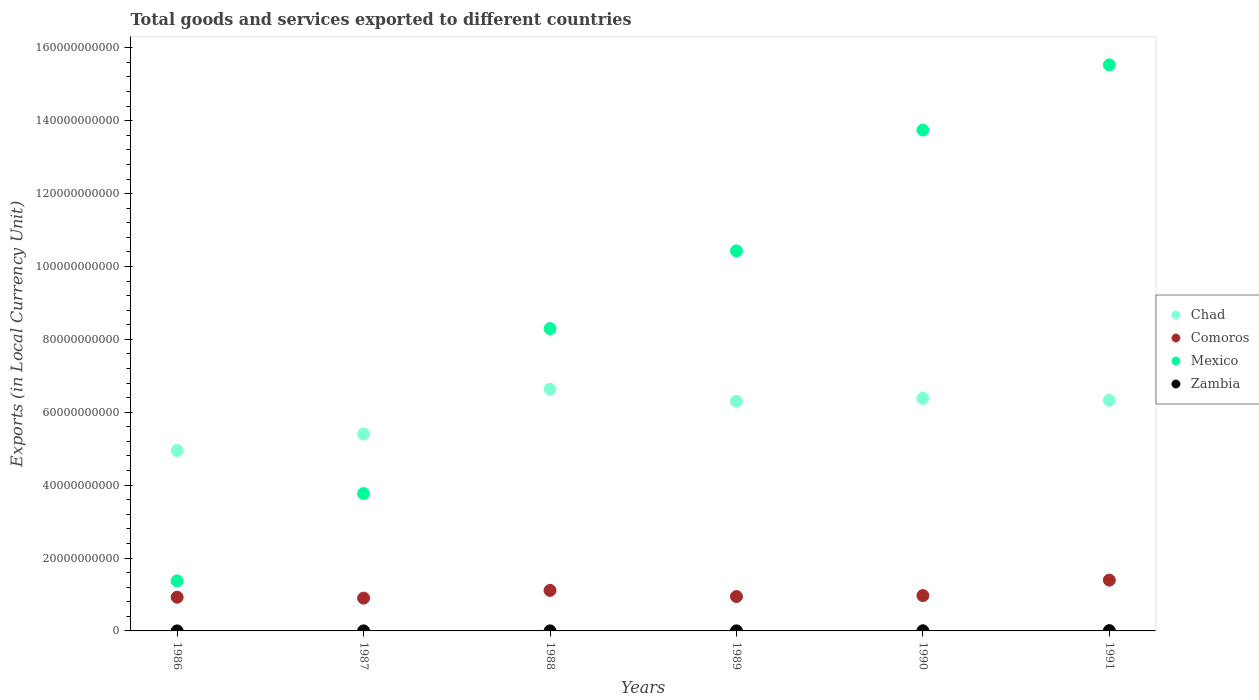How many different coloured dotlines are there?
Offer a terse response. 4. Is the number of dotlines equal to the number of legend labels?
Ensure brevity in your answer.  Yes. What is the Amount of goods and services exports in Mexico in 1986?
Your answer should be compact. 1.37e+1. Across all years, what is the maximum Amount of goods and services exports in Zambia?
Give a very brief answer. 7.56e+07. Across all years, what is the minimum Amount of goods and services exports in Zambia?
Provide a short and direct response. 5.46e+06. In which year was the Amount of goods and services exports in Mexico minimum?
Provide a short and direct response. 1986. What is the total Amount of goods and services exports in Chad in the graph?
Your answer should be very brief. 3.60e+11. What is the difference between the Amount of goods and services exports in Mexico in 1990 and that in 1991?
Your response must be concise. -1.79e+1. What is the difference between the Amount of goods and services exports in Chad in 1991 and the Amount of goods and services exports in Zambia in 1988?
Keep it short and to the point. 6.33e+1. What is the average Amount of goods and services exports in Mexico per year?
Offer a very short reply. 8.86e+1. In the year 1987, what is the difference between the Amount of goods and services exports in Comoros and Amount of goods and services exports in Chad?
Your answer should be compact. -4.50e+1. In how many years, is the Amount of goods and services exports in Mexico greater than 32000000000 LCU?
Offer a terse response. 5. What is the ratio of the Amount of goods and services exports in Zambia in 1987 to that in 1990?
Your answer should be compact. 0.21. Is the difference between the Amount of goods and services exports in Comoros in 1987 and 1990 greater than the difference between the Amount of goods and services exports in Chad in 1987 and 1990?
Your answer should be very brief. Yes. What is the difference between the highest and the second highest Amount of goods and services exports in Comoros?
Provide a succinct answer. 2.82e+09. What is the difference between the highest and the lowest Amount of goods and services exports in Chad?
Provide a short and direct response. 1.68e+1. Is it the case that in every year, the sum of the Amount of goods and services exports in Zambia and Amount of goods and services exports in Mexico  is greater than the Amount of goods and services exports in Chad?
Ensure brevity in your answer.  No. What is the difference between two consecutive major ticks on the Y-axis?
Your response must be concise. 2.00e+1. Where does the legend appear in the graph?
Give a very brief answer. Center right. What is the title of the graph?
Keep it short and to the point. Total goods and services exported to different countries. What is the label or title of the Y-axis?
Make the answer very short. Exports (in Local Currency Unit). What is the Exports (in Local Currency Unit) in Chad in 1986?
Offer a terse response. 4.95e+1. What is the Exports (in Local Currency Unit) in Comoros in 1986?
Offer a terse response. 9.25e+09. What is the Exports (in Local Currency Unit) of Mexico in 1986?
Your answer should be very brief. 1.37e+1. What is the Exports (in Local Currency Unit) in Zambia in 1986?
Provide a succinct answer. 5.46e+06. What is the Exports (in Local Currency Unit) of Chad in 1987?
Provide a succinct answer. 5.40e+1. What is the Exports (in Local Currency Unit) in Comoros in 1987?
Provide a succinct answer. 9.00e+09. What is the Exports (in Local Currency Unit) of Mexico in 1987?
Offer a terse response. 3.77e+1. What is the Exports (in Local Currency Unit) in Zambia in 1987?
Your answer should be compact. 8.51e+06. What is the Exports (in Local Currency Unit) of Chad in 1988?
Offer a very short reply. 6.63e+1. What is the Exports (in Local Currency Unit) of Comoros in 1988?
Make the answer very short. 1.11e+1. What is the Exports (in Local Currency Unit) of Mexico in 1988?
Give a very brief answer. 8.30e+1. What is the Exports (in Local Currency Unit) in Zambia in 1988?
Your response must be concise. 1.03e+07. What is the Exports (in Local Currency Unit) of Chad in 1989?
Ensure brevity in your answer.  6.30e+1. What is the Exports (in Local Currency Unit) of Comoros in 1989?
Your answer should be very brief. 9.44e+09. What is the Exports (in Local Currency Unit) of Mexico in 1989?
Offer a very short reply. 1.04e+11. What is the Exports (in Local Currency Unit) in Zambia in 1989?
Give a very brief answer. 1.48e+07. What is the Exports (in Local Currency Unit) in Chad in 1990?
Your response must be concise. 6.38e+1. What is the Exports (in Local Currency Unit) in Comoros in 1990?
Give a very brief answer. 9.70e+09. What is the Exports (in Local Currency Unit) of Mexico in 1990?
Make the answer very short. 1.37e+11. What is the Exports (in Local Currency Unit) in Zambia in 1990?
Your answer should be compact. 4.07e+07. What is the Exports (in Local Currency Unit) in Chad in 1991?
Keep it short and to the point. 6.33e+1. What is the Exports (in Local Currency Unit) in Comoros in 1991?
Make the answer very short. 1.39e+1. What is the Exports (in Local Currency Unit) in Mexico in 1991?
Offer a very short reply. 1.55e+11. What is the Exports (in Local Currency Unit) of Zambia in 1991?
Your answer should be compact. 7.56e+07. Across all years, what is the maximum Exports (in Local Currency Unit) in Chad?
Provide a short and direct response. 6.63e+1. Across all years, what is the maximum Exports (in Local Currency Unit) in Comoros?
Give a very brief answer. 1.39e+1. Across all years, what is the maximum Exports (in Local Currency Unit) in Mexico?
Your response must be concise. 1.55e+11. Across all years, what is the maximum Exports (in Local Currency Unit) in Zambia?
Your answer should be very brief. 7.56e+07. Across all years, what is the minimum Exports (in Local Currency Unit) in Chad?
Your answer should be compact. 4.95e+1. Across all years, what is the minimum Exports (in Local Currency Unit) of Comoros?
Your answer should be compact. 9.00e+09. Across all years, what is the minimum Exports (in Local Currency Unit) in Mexico?
Make the answer very short. 1.37e+1. Across all years, what is the minimum Exports (in Local Currency Unit) of Zambia?
Give a very brief answer. 5.46e+06. What is the total Exports (in Local Currency Unit) of Chad in the graph?
Give a very brief answer. 3.60e+11. What is the total Exports (in Local Currency Unit) in Comoros in the graph?
Your response must be concise. 6.24e+1. What is the total Exports (in Local Currency Unit) of Mexico in the graph?
Ensure brevity in your answer.  5.31e+11. What is the total Exports (in Local Currency Unit) of Zambia in the graph?
Offer a very short reply. 1.55e+08. What is the difference between the Exports (in Local Currency Unit) of Chad in 1986 and that in 1987?
Give a very brief answer. -4.49e+09. What is the difference between the Exports (in Local Currency Unit) in Comoros in 1986 and that in 1987?
Your response must be concise. 2.51e+08. What is the difference between the Exports (in Local Currency Unit) of Mexico in 1986 and that in 1987?
Provide a succinct answer. -2.40e+1. What is the difference between the Exports (in Local Currency Unit) of Zambia in 1986 and that in 1987?
Offer a terse response. -3.05e+06. What is the difference between the Exports (in Local Currency Unit) in Chad in 1986 and that in 1988?
Give a very brief answer. -1.68e+1. What is the difference between the Exports (in Local Currency Unit) of Comoros in 1986 and that in 1988?
Offer a terse response. -1.86e+09. What is the difference between the Exports (in Local Currency Unit) of Mexico in 1986 and that in 1988?
Your answer should be very brief. -6.92e+1. What is the difference between the Exports (in Local Currency Unit) of Zambia in 1986 and that in 1988?
Ensure brevity in your answer.  -4.80e+06. What is the difference between the Exports (in Local Currency Unit) in Chad in 1986 and that in 1989?
Provide a short and direct response. -1.35e+1. What is the difference between the Exports (in Local Currency Unit) in Comoros in 1986 and that in 1989?
Give a very brief answer. -1.84e+08. What is the difference between the Exports (in Local Currency Unit) of Mexico in 1986 and that in 1989?
Give a very brief answer. -9.05e+1. What is the difference between the Exports (in Local Currency Unit) in Zambia in 1986 and that in 1989?
Make the answer very short. -9.33e+06. What is the difference between the Exports (in Local Currency Unit) in Chad in 1986 and that in 1990?
Offer a terse response. -1.43e+1. What is the difference between the Exports (in Local Currency Unit) of Comoros in 1986 and that in 1990?
Give a very brief answer. -4.51e+08. What is the difference between the Exports (in Local Currency Unit) in Mexico in 1986 and that in 1990?
Provide a succinct answer. -1.24e+11. What is the difference between the Exports (in Local Currency Unit) in Zambia in 1986 and that in 1990?
Offer a terse response. -3.52e+07. What is the difference between the Exports (in Local Currency Unit) in Chad in 1986 and that in 1991?
Provide a succinct answer. -1.38e+1. What is the difference between the Exports (in Local Currency Unit) of Comoros in 1986 and that in 1991?
Ensure brevity in your answer.  -4.68e+09. What is the difference between the Exports (in Local Currency Unit) of Mexico in 1986 and that in 1991?
Make the answer very short. -1.42e+11. What is the difference between the Exports (in Local Currency Unit) in Zambia in 1986 and that in 1991?
Make the answer very short. -7.01e+07. What is the difference between the Exports (in Local Currency Unit) in Chad in 1987 and that in 1988?
Your response must be concise. -1.23e+1. What is the difference between the Exports (in Local Currency Unit) of Comoros in 1987 and that in 1988?
Ensure brevity in your answer.  -2.11e+09. What is the difference between the Exports (in Local Currency Unit) in Mexico in 1987 and that in 1988?
Your answer should be very brief. -4.53e+1. What is the difference between the Exports (in Local Currency Unit) in Zambia in 1987 and that in 1988?
Your answer should be compact. -1.75e+06. What is the difference between the Exports (in Local Currency Unit) of Chad in 1987 and that in 1989?
Provide a succinct answer. -9.01e+09. What is the difference between the Exports (in Local Currency Unit) of Comoros in 1987 and that in 1989?
Your answer should be compact. -4.35e+08. What is the difference between the Exports (in Local Currency Unit) in Mexico in 1987 and that in 1989?
Provide a succinct answer. -6.66e+1. What is the difference between the Exports (in Local Currency Unit) of Zambia in 1987 and that in 1989?
Ensure brevity in your answer.  -6.28e+06. What is the difference between the Exports (in Local Currency Unit) in Chad in 1987 and that in 1990?
Ensure brevity in your answer.  -9.79e+09. What is the difference between the Exports (in Local Currency Unit) of Comoros in 1987 and that in 1990?
Give a very brief answer. -7.02e+08. What is the difference between the Exports (in Local Currency Unit) in Mexico in 1987 and that in 1990?
Ensure brevity in your answer.  -9.97e+1. What is the difference between the Exports (in Local Currency Unit) in Zambia in 1987 and that in 1990?
Your answer should be very brief. -3.22e+07. What is the difference between the Exports (in Local Currency Unit) of Chad in 1987 and that in 1991?
Provide a short and direct response. -9.27e+09. What is the difference between the Exports (in Local Currency Unit) in Comoros in 1987 and that in 1991?
Provide a short and direct response. -4.93e+09. What is the difference between the Exports (in Local Currency Unit) in Mexico in 1987 and that in 1991?
Your response must be concise. -1.18e+11. What is the difference between the Exports (in Local Currency Unit) of Zambia in 1987 and that in 1991?
Keep it short and to the point. -6.70e+07. What is the difference between the Exports (in Local Currency Unit) of Chad in 1988 and that in 1989?
Ensure brevity in your answer.  3.29e+09. What is the difference between the Exports (in Local Currency Unit) in Comoros in 1988 and that in 1989?
Your response must be concise. 1.68e+09. What is the difference between the Exports (in Local Currency Unit) in Mexico in 1988 and that in 1989?
Your answer should be compact. -2.13e+1. What is the difference between the Exports (in Local Currency Unit) in Zambia in 1988 and that in 1989?
Your answer should be very brief. -4.53e+06. What is the difference between the Exports (in Local Currency Unit) in Chad in 1988 and that in 1990?
Provide a succinct answer. 2.51e+09. What is the difference between the Exports (in Local Currency Unit) in Comoros in 1988 and that in 1990?
Offer a terse response. 1.41e+09. What is the difference between the Exports (in Local Currency Unit) of Mexico in 1988 and that in 1990?
Give a very brief answer. -5.45e+1. What is the difference between the Exports (in Local Currency Unit) in Zambia in 1988 and that in 1990?
Keep it short and to the point. -3.04e+07. What is the difference between the Exports (in Local Currency Unit) in Chad in 1988 and that in 1991?
Keep it short and to the point. 3.03e+09. What is the difference between the Exports (in Local Currency Unit) in Comoros in 1988 and that in 1991?
Ensure brevity in your answer.  -2.82e+09. What is the difference between the Exports (in Local Currency Unit) of Mexico in 1988 and that in 1991?
Offer a terse response. -7.24e+1. What is the difference between the Exports (in Local Currency Unit) of Zambia in 1988 and that in 1991?
Your response must be concise. -6.53e+07. What is the difference between the Exports (in Local Currency Unit) in Chad in 1989 and that in 1990?
Give a very brief answer. -7.80e+08. What is the difference between the Exports (in Local Currency Unit) of Comoros in 1989 and that in 1990?
Give a very brief answer. -2.67e+08. What is the difference between the Exports (in Local Currency Unit) of Mexico in 1989 and that in 1990?
Provide a succinct answer. -3.32e+1. What is the difference between the Exports (in Local Currency Unit) of Zambia in 1989 and that in 1990?
Your response must be concise. -2.59e+07. What is the difference between the Exports (in Local Currency Unit) of Chad in 1989 and that in 1991?
Provide a succinct answer. -2.60e+08. What is the difference between the Exports (in Local Currency Unit) in Comoros in 1989 and that in 1991?
Make the answer very short. -4.50e+09. What is the difference between the Exports (in Local Currency Unit) in Mexico in 1989 and that in 1991?
Make the answer very short. -5.11e+1. What is the difference between the Exports (in Local Currency Unit) in Zambia in 1989 and that in 1991?
Provide a succinct answer. -6.08e+07. What is the difference between the Exports (in Local Currency Unit) of Chad in 1990 and that in 1991?
Give a very brief answer. 5.20e+08. What is the difference between the Exports (in Local Currency Unit) in Comoros in 1990 and that in 1991?
Your response must be concise. -4.23e+09. What is the difference between the Exports (in Local Currency Unit) of Mexico in 1990 and that in 1991?
Make the answer very short. -1.79e+1. What is the difference between the Exports (in Local Currency Unit) of Zambia in 1990 and that in 1991?
Provide a short and direct response. -3.49e+07. What is the difference between the Exports (in Local Currency Unit) of Chad in 1986 and the Exports (in Local Currency Unit) of Comoros in 1987?
Offer a very short reply. 4.05e+1. What is the difference between the Exports (in Local Currency Unit) in Chad in 1986 and the Exports (in Local Currency Unit) in Mexico in 1987?
Your response must be concise. 1.18e+1. What is the difference between the Exports (in Local Currency Unit) in Chad in 1986 and the Exports (in Local Currency Unit) in Zambia in 1987?
Give a very brief answer. 4.95e+1. What is the difference between the Exports (in Local Currency Unit) in Comoros in 1986 and the Exports (in Local Currency Unit) in Mexico in 1987?
Give a very brief answer. -2.84e+1. What is the difference between the Exports (in Local Currency Unit) in Comoros in 1986 and the Exports (in Local Currency Unit) in Zambia in 1987?
Provide a short and direct response. 9.24e+09. What is the difference between the Exports (in Local Currency Unit) in Mexico in 1986 and the Exports (in Local Currency Unit) in Zambia in 1987?
Your answer should be very brief. 1.37e+1. What is the difference between the Exports (in Local Currency Unit) in Chad in 1986 and the Exports (in Local Currency Unit) in Comoros in 1988?
Ensure brevity in your answer.  3.84e+1. What is the difference between the Exports (in Local Currency Unit) in Chad in 1986 and the Exports (in Local Currency Unit) in Mexico in 1988?
Give a very brief answer. -3.34e+1. What is the difference between the Exports (in Local Currency Unit) of Chad in 1986 and the Exports (in Local Currency Unit) of Zambia in 1988?
Your answer should be compact. 4.95e+1. What is the difference between the Exports (in Local Currency Unit) of Comoros in 1986 and the Exports (in Local Currency Unit) of Mexico in 1988?
Offer a very short reply. -7.37e+1. What is the difference between the Exports (in Local Currency Unit) of Comoros in 1986 and the Exports (in Local Currency Unit) of Zambia in 1988?
Offer a very short reply. 9.24e+09. What is the difference between the Exports (in Local Currency Unit) of Mexico in 1986 and the Exports (in Local Currency Unit) of Zambia in 1988?
Keep it short and to the point. 1.37e+1. What is the difference between the Exports (in Local Currency Unit) of Chad in 1986 and the Exports (in Local Currency Unit) of Comoros in 1989?
Ensure brevity in your answer.  4.01e+1. What is the difference between the Exports (in Local Currency Unit) in Chad in 1986 and the Exports (in Local Currency Unit) in Mexico in 1989?
Your response must be concise. -5.47e+1. What is the difference between the Exports (in Local Currency Unit) in Chad in 1986 and the Exports (in Local Currency Unit) in Zambia in 1989?
Offer a very short reply. 4.95e+1. What is the difference between the Exports (in Local Currency Unit) in Comoros in 1986 and the Exports (in Local Currency Unit) in Mexico in 1989?
Keep it short and to the point. -9.50e+1. What is the difference between the Exports (in Local Currency Unit) in Comoros in 1986 and the Exports (in Local Currency Unit) in Zambia in 1989?
Provide a succinct answer. 9.24e+09. What is the difference between the Exports (in Local Currency Unit) of Mexico in 1986 and the Exports (in Local Currency Unit) of Zambia in 1989?
Provide a succinct answer. 1.37e+1. What is the difference between the Exports (in Local Currency Unit) of Chad in 1986 and the Exports (in Local Currency Unit) of Comoros in 1990?
Provide a succinct answer. 3.98e+1. What is the difference between the Exports (in Local Currency Unit) in Chad in 1986 and the Exports (in Local Currency Unit) in Mexico in 1990?
Your answer should be very brief. -8.79e+1. What is the difference between the Exports (in Local Currency Unit) in Chad in 1986 and the Exports (in Local Currency Unit) in Zambia in 1990?
Keep it short and to the point. 4.95e+1. What is the difference between the Exports (in Local Currency Unit) of Comoros in 1986 and the Exports (in Local Currency Unit) of Mexico in 1990?
Provide a succinct answer. -1.28e+11. What is the difference between the Exports (in Local Currency Unit) of Comoros in 1986 and the Exports (in Local Currency Unit) of Zambia in 1990?
Provide a succinct answer. 9.21e+09. What is the difference between the Exports (in Local Currency Unit) in Mexico in 1986 and the Exports (in Local Currency Unit) in Zambia in 1990?
Offer a very short reply. 1.37e+1. What is the difference between the Exports (in Local Currency Unit) in Chad in 1986 and the Exports (in Local Currency Unit) in Comoros in 1991?
Your answer should be compact. 3.56e+1. What is the difference between the Exports (in Local Currency Unit) of Chad in 1986 and the Exports (in Local Currency Unit) of Mexico in 1991?
Offer a terse response. -1.06e+11. What is the difference between the Exports (in Local Currency Unit) in Chad in 1986 and the Exports (in Local Currency Unit) in Zambia in 1991?
Your answer should be compact. 4.95e+1. What is the difference between the Exports (in Local Currency Unit) in Comoros in 1986 and the Exports (in Local Currency Unit) in Mexico in 1991?
Offer a very short reply. -1.46e+11. What is the difference between the Exports (in Local Currency Unit) of Comoros in 1986 and the Exports (in Local Currency Unit) of Zambia in 1991?
Offer a terse response. 9.18e+09. What is the difference between the Exports (in Local Currency Unit) in Mexico in 1986 and the Exports (in Local Currency Unit) in Zambia in 1991?
Offer a terse response. 1.37e+1. What is the difference between the Exports (in Local Currency Unit) of Chad in 1987 and the Exports (in Local Currency Unit) of Comoros in 1988?
Your answer should be very brief. 4.29e+1. What is the difference between the Exports (in Local Currency Unit) in Chad in 1987 and the Exports (in Local Currency Unit) in Mexico in 1988?
Provide a short and direct response. -2.89e+1. What is the difference between the Exports (in Local Currency Unit) of Chad in 1987 and the Exports (in Local Currency Unit) of Zambia in 1988?
Ensure brevity in your answer.  5.40e+1. What is the difference between the Exports (in Local Currency Unit) in Comoros in 1987 and the Exports (in Local Currency Unit) in Mexico in 1988?
Offer a terse response. -7.40e+1. What is the difference between the Exports (in Local Currency Unit) of Comoros in 1987 and the Exports (in Local Currency Unit) of Zambia in 1988?
Keep it short and to the point. 8.99e+09. What is the difference between the Exports (in Local Currency Unit) in Mexico in 1987 and the Exports (in Local Currency Unit) in Zambia in 1988?
Make the answer very short. 3.77e+1. What is the difference between the Exports (in Local Currency Unit) in Chad in 1987 and the Exports (in Local Currency Unit) in Comoros in 1989?
Your answer should be compact. 4.46e+1. What is the difference between the Exports (in Local Currency Unit) of Chad in 1987 and the Exports (in Local Currency Unit) of Mexico in 1989?
Your answer should be very brief. -5.02e+1. What is the difference between the Exports (in Local Currency Unit) of Chad in 1987 and the Exports (in Local Currency Unit) of Zambia in 1989?
Provide a succinct answer. 5.40e+1. What is the difference between the Exports (in Local Currency Unit) in Comoros in 1987 and the Exports (in Local Currency Unit) in Mexico in 1989?
Provide a succinct answer. -9.53e+1. What is the difference between the Exports (in Local Currency Unit) of Comoros in 1987 and the Exports (in Local Currency Unit) of Zambia in 1989?
Provide a succinct answer. 8.99e+09. What is the difference between the Exports (in Local Currency Unit) of Mexico in 1987 and the Exports (in Local Currency Unit) of Zambia in 1989?
Make the answer very short. 3.77e+1. What is the difference between the Exports (in Local Currency Unit) of Chad in 1987 and the Exports (in Local Currency Unit) of Comoros in 1990?
Make the answer very short. 4.43e+1. What is the difference between the Exports (in Local Currency Unit) of Chad in 1987 and the Exports (in Local Currency Unit) of Mexico in 1990?
Ensure brevity in your answer.  -8.34e+1. What is the difference between the Exports (in Local Currency Unit) in Chad in 1987 and the Exports (in Local Currency Unit) in Zambia in 1990?
Provide a short and direct response. 5.40e+1. What is the difference between the Exports (in Local Currency Unit) in Comoros in 1987 and the Exports (in Local Currency Unit) in Mexico in 1990?
Your answer should be compact. -1.28e+11. What is the difference between the Exports (in Local Currency Unit) of Comoros in 1987 and the Exports (in Local Currency Unit) of Zambia in 1990?
Your response must be concise. 8.96e+09. What is the difference between the Exports (in Local Currency Unit) of Mexico in 1987 and the Exports (in Local Currency Unit) of Zambia in 1990?
Your answer should be very brief. 3.77e+1. What is the difference between the Exports (in Local Currency Unit) of Chad in 1987 and the Exports (in Local Currency Unit) of Comoros in 1991?
Make the answer very short. 4.01e+1. What is the difference between the Exports (in Local Currency Unit) of Chad in 1987 and the Exports (in Local Currency Unit) of Mexico in 1991?
Give a very brief answer. -1.01e+11. What is the difference between the Exports (in Local Currency Unit) of Chad in 1987 and the Exports (in Local Currency Unit) of Zambia in 1991?
Your response must be concise. 5.39e+1. What is the difference between the Exports (in Local Currency Unit) of Comoros in 1987 and the Exports (in Local Currency Unit) of Mexico in 1991?
Ensure brevity in your answer.  -1.46e+11. What is the difference between the Exports (in Local Currency Unit) of Comoros in 1987 and the Exports (in Local Currency Unit) of Zambia in 1991?
Give a very brief answer. 8.92e+09. What is the difference between the Exports (in Local Currency Unit) of Mexico in 1987 and the Exports (in Local Currency Unit) of Zambia in 1991?
Offer a terse response. 3.76e+1. What is the difference between the Exports (in Local Currency Unit) in Chad in 1988 and the Exports (in Local Currency Unit) in Comoros in 1989?
Keep it short and to the point. 5.69e+1. What is the difference between the Exports (in Local Currency Unit) of Chad in 1988 and the Exports (in Local Currency Unit) of Mexico in 1989?
Keep it short and to the point. -3.79e+1. What is the difference between the Exports (in Local Currency Unit) in Chad in 1988 and the Exports (in Local Currency Unit) in Zambia in 1989?
Your answer should be very brief. 6.63e+1. What is the difference between the Exports (in Local Currency Unit) of Comoros in 1988 and the Exports (in Local Currency Unit) of Mexico in 1989?
Offer a terse response. -9.32e+1. What is the difference between the Exports (in Local Currency Unit) in Comoros in 1988 and the Exports (in Local Currency Unit) in Zambia in 1989?
Your answer should be compact. 1.11e+1. What is the difference between the Exports (in Local Currency Unit) in Mexico in 1988 and the Exports (in Local Currency Unit) in Zambia in 1989?
Provide a short and direct response. 8.29e+1. What is the difference between the Exports (in Local Currency Unit) in Chad in 1988 and the Exports (in Local Currency Unit) in Comoros in 1990?
Provide a succinct answer. 5.66e+1. What is the difference between the Exports (in Local Currency Unit) in Chad in 1988 and the Exports (in Local Currency Unit) in Mexico in 1990?
Make the answer very short. -7.11e+1. What is the difference between the Exports (in Local Currency Unit) of Chad in 1988 and the Exports (in Local Currency Unit) of Zambia in 1990?
Make the answer very short. 6.63e+1. What is the difference between the Exports (in Local Currency Unit) in Comoros in 1988 and the Exports (in Local Currency Unit) in Mexico in 1990?
Your response must be concise. -1.26e+11. What is the difference between the Exports (in Local Currency Unit) in Comoros in 1988 and the Exports (in Local Currency Unit) in Zambia in 1990?
Make the answer very short. 1.11e+1. What is the difference between the Exports (in Local Currency Unit) of Mexico in 1988 and the Exports (in Local Currency Unit) of Zambia in 1990?
Offer a very short reply. 8.29e+1. What is the difference between the Exports (in Local Currency Unit) in Chad in 1988 and the Exports (in Local Currency Unit) in Comoros in 1991?
Provide a short and direct response. 5.24e+1. What is the difference between the Exports (in Local Currency Unit) of Chad in 1988 and the Exports (in Local Currency Unit) of Mexico in 1991?
Offer a terse response. -8.90e+1. What is the difference between the Exports (in Local Currency Unit) in Chad in 1988 and the Exports (in Local Currency Unit) in Zambia in 1991?
Ensure brevity in your answer.  6.62e+1. What is the difference between the Exports (in Local Currency Unit) of Comoros in 1988 and the Exports (in Local Currency Unit) of Mexico in 1991?
Give a very brief answer. -1.44e+11. What is the difference between the Exports (in Local Currency Unit) of Comoros in 1988 and the Exports (in Local Currency Unit) of Zambia in 1991?
Your answer should be compact. 1.10e+1. What is the difference between the Exports (in Local Currency Unit) in Mexico in 1988 and the Exports (in Local Currency Unit) in Zambia in 1991?
Provide a succinct answer. 8.29e+1. What is the difference between the Exports (in Local Currency Unit) of Chad in 1989 and the Exports (in Local Currency Unit) of Comoros in 1990?
Offer a terse response. 5.33e+1. What is the difference between the Exports (in Local Currency Unit) in Chad in 1989 and the Exports (in Local Currency Unit) in Mexico in 1990?
Keep it short and to the point. -7.44e+1. What is the difference between the Exports (in Local Currency Unit) in Chad in 1989 and the Exports (in Local Currency Unit) in Zambia in 1990?
Ensure brevity in your answer.  6.30e+1. What is the difference between the Exports (in Local Currency Unit) in Comoros in 1989 and the Exports (in Local Currency Unit) in Mexico in 1990?
Your answer should be compact. -1.28e+11. What is the difference between the Exports (in Local Currency Unit) in Comoros in 1989 and the Exports (in Local Currency Unit) in Zambia in 1990?
Your answer should be compact. 9.39e+09. What is the difference between the Exports (in Local Currency Unit) of Mexico in 1989 and the Exports (in Local Currency Unit) of Zambia in 1990?
Your response must be concise. 1.04e+11. What is the difference between the Exports (in Local Currency Unit) of Chad in 1989 and the Exports (in Local Currency Unit) of Comoros in 1991?
Keep it short and to the point. 4.91e+1. What is the difference between the Exports (in Local Currency Unit) of Chad in 1989 and the Exports (in Local Currency Unit) of Mexico in 1991?
Your response must be concise. -9.23e+1. What is the difference between the Exports (in Local Currency Unit) in Chad in 1989 and the Exports (in Local Currency Unit) in Zambia in 1991?
Make the answer very short. 6.30e+1. What is the difference between the Exports (in Local Currency Unit) of Comoros in 1989 and the Exports (in Local Currency Unit) of Mexico in 1991?
Offer a terse response. -1.46e+11. What is the difference between the Exports (in Local Currency Unit) in Comoros in 1989 and the Exports (in Local Currency Unit) in Zambia in 1991?
Give a very brief answer. 9.36e+09. What is the difference between the Exports (in Local Currency Unit) of Mexico in 1989 and the Exports (in Local Currency Unit) of Zambia in 1991?
Make the answer very short. 1.04e+11. What is the difference between the Exports (in Local Currency Unit) in Chad in 1990 and the Exports (in Local Currency Unit) in Comoros in 1991?
Keep it short and to the point. 4.99e+1. What is the difference between the Exports (in Local Currency Unit) of Chad in 1990 and the Exports (in Local Currency Unit) of Mexico in 1991?
Offer a very short reply. -9.15e+1. What is the difference between the Exports (in Local Currency Unit) of Chad in 1990 and the Exports (in Local Currency Unit) of Zambia in 1991?
Give a very brief answer. 6.37e+1. What is the difference between the Exports (in Local Currency Unit) in Comoros in 1990 and the Exports (in Local Currency Unit) in Mexico in 1991?
Offer a terse response. -1.46e+11. What is the difference between the Exports (in Local Currency Unit) in Comoros in 1990 and the Exports (in Local Currency Unit) in Zambia in 1991?
Keep it short and to the point. 9.63e+09. What is the difference between the Exports (in Local Currency Unit) of Mexico in 1990 and the Exports (in Local Currency Unit) of Zambia in 1991?
Your answer should be very brief. 1.37e+11. What is the average Exports (in Local Currency Unit) of Chad per year?
Your response must be concise. 6.00e+1. What is the average Exports (in Local Currency Unit) in Comoros per year?
Make the answer very short. 1.04e+1. What is the average Exports (in Local Currency Unit) in Mexico per year?
Provide a succinct answer. 8.86e+1. What is the average Exports (in Local Currency Unit) in Zambia per year?
Your answer should be compact. 2.59e+07. In the year 1986, what is the difference between the Exports (in Local Currency Unit) of Chad and Exports (in Local Currency Unit) of Comoros?
Provide a succinct answer. 4.03e+1. In the year 1986, what is the difference between the Exports (in Local Currency Unit) in Chad and Exports (in Local Currency Unit) in Mexico?
Offer a terse response. 3.58e+1. In the year 1986, what is the difference between the Exports (in Local Currency Unit) of Chad and Exports (in Local Currency Unit) of Zambia?
Make the answer very short. 4.95e+1. In the year 1986, what is the difference between the Exports (in Local Currency Unit) of Comoros and Exports (in Local Currency Unit) of Mexico?
Give a very brief answer. -4.48e+09. In the year 1986, what is the difference between the Exports (in Local Currency Unit) in Comoros and Exports (in Local Currency Unit) in Zambia?
Your response must be concise. 9.25e+09. In the year 1986, what is the difference between the Exports (in Local Currency Unit) in Mexico and Exports (in Local Currency Unit) in Zambia?
Offer a very short reply. 1.37e+1. In the year 1987, what is the difference between the Exports (in Local Currency Unit) of Chad and Exports (in Local Currency Unit) of Comoros?
Offer a very short reply. 4.50e+1. In the year 1987, what is the difference between the Exports (in Local Currency Unit) in Chad and Exports (in Local Currency Unit) in Mexico?
Your answer should be compact. 1.63e+1. In the year 1987, what is the difference between the Exports (in Local Currency Unit) of Chad and Exports (in Local Currency Unit) of Zambia?
Your answer should be compact. 5.40e+1. In the year 1987, what is the difference between the Exports (in Local Currency Unit) in Comoros and Exports (in Local Currency Unit) in Mexico?
Your answer should be compact. -2.87e+1. In the year 1987, what is the difference between the Exports (in Local Currency Unit) in Comoros and Exports (in Local Currency Unit) in Zambia?
Provide a succinct answer. 8.99e+09. In the year 1987, what is the difference between the Exports (in Local Currency Unit) in Mexico and Exports (in Local Currency Unit) in Zambia?
Your answer should be compact. 3.77e+1. In the year 1988, what is the difference between the Exports (in Local Currency Unit) in Chad and Exports (in Local Currency Unit) in Comoros?
Give a very brief answer. 5.52e+1. In the year 1988, what is the difference between the Exports (in Local Currency Unit) of Chad and Exports (in Local Currency Unit) of Mexico?
Provide a succinct answer. -1.66e+1. In the year 1988, what is the difference between the Exports (in Local Currency Unit) in Chad and Exports (in Local Currency Unit) in Zambia?
Provide a short and direct response. 6.63e+1. In the year 1988, what is the difference between the Exports (in Local Currency Unit) of Comoros and Exports (in Local Currency Unit) of Mexico?
Offer a very short reply. -7.18e+1. In the year 1988, what is the difference between the Exports (in Local Currency Unit) of Comoros and Exports (in Local Currency Unit) of Zambia?
Give a very brief answer. 1.11e+1. In the year 1988, what is the difference between the Exports (in Local Currency Unit) of Mexico and Exports (in Local Currency Unit) of Zambia?
Give a very brief answer. 8.30e+1. In the year 1989, what is the difference between the Exports (in Local Currency Unit) in Chad and Exports (in Local Currency Unit) in Comoros?
Provide a short and direct response. 5.36e+1. In the year 1989, what is the difference between the Exports (in Local Currency Unit) in Chad and Exports (in Local Currency Unit) in Mexico?
Ensure brevity in your answer.  -4.12e+1. In the year 1989, what is the difference between the Exports (in Local Currency Unit) of Chad and Exports (in Local Currency Unit) of Zambia?
Your response must be concise. 6.30e+1. In the year 1989, what is the difference between the Exports (in Local Currency Unit) in Comoros and Exports (in Local Currency Unit) in Mexico?
Give a very brief answer. -9.48e+1. In the year 1989, what is the difference between the Exports (in Local Currency Unit) in Comoros and Exports (in Local Currency Unit) in Zambia?
Your answer should be compact. 9.42e+09. In the year 1989, what is the difference between the Exports (in Local Currency Unit) in Mexico and Exports (in Local Currency Unit) in Zambia?
Give a very brief answer. 1.04e+11. In the year 1990, what is the difference between the Exports (in Local Currency Unit) of Chad and Exports (in Local Currency Unit) of Comoros?
Offer a very short reply. 5.41e+1. In the year 1990, what is the difference between the Exports (in Local Currency Unit) in Chad and Exports (in Local Currency Unit) in Mexico?
Your response must be concise. -7.36e+1. In the year 1990, what is the difference between the Exports (in Local Currency Unit) of Chad and Exports (in Local Currency Unit) of Zambia?
Your answer should be very brief. 6.38e+1. In the year 1990, what is the difference between the Exports (in Local Currency Unit) of Comoros and Exports (in Local Currency Unit) of Mexico?
Your response must be concise. -1.28e+11. In the year 1990, what is the difference between the Exports (in Local Currency Unit) of Comoros and Exports (in Local Currency Unit) of Zambia?
Make the answer very short. 9.66e+09. In the year 1990, what is the difference between the Exports (in Local Currency Unit) in Mexico and Exports (in Local Currency Unit) in Zambia?
Your response must be concise. 1.37e+11. In the year 1991, what is the difference between the Exports (in Local Currency Unit) of Chad and Exports (in Local Currency Unit) of Comoros?
Make the answer very short. 4.94e+1. In the year 1991, what is the difference between the Exports (in Local Currency Unit) in Chad and Exports (in Local Currency Unit) in Mexico?
Offer a terse response. -9.20e+1. In the year 1991, what is the difference between the Exports (in Local Currency Unit) of Chad and Exports (in Local Currency Unit) of Zambia?
Make the answer very short. 6.32e+1. In the year 1991, what is the difference between the Exports (in Local Currency Unit) of Comoros and Exports (in Local Currency Unit) of Mexico?
Your response must be concise. -1.41e+11. In the year 1991, what is the difference between the Exports (in Local Currency Unit) of Comoros and Exports (in Local Currency Unit) of Zambia?
Provide a short and direct response. 1.39e+1. In the year 1991, what is the difference between the Exports (in Local Currency Unit) in Mexico and Exports (in Local Currency Unit) in Zambia?
Give a very brief answer. 1.55e+11. What is the ratio of the Exports (in Local Currency Unit) in Chad in 1986 to that in 1987?
Your answer should be compact. 0.92. What is the ratio of the Exports (in Local Currency Unit) in Comoros in 1986 to that in 1987?
Your answer should be compact. 1.03. What is the ratio of the Exports (in Local Currency Unit) of Mexico in 1986 to that in 1987?
Keep it short and to the point. 0.36. What is the ratio of the Exports (in Local Currency Unit) of Zambia in 1986 to that in 1987?
Your response must be concise. 0.64. What is the ratio of the Exports (in Local Currency Unit) in Chad in 1986 to that in 1988?
Keep it short and to the point. 0.75. What is the ratio of the Exports (in Local Currency Unit) in Comoros in 1986 to that in 1988?
Offer a terse response. 0.83. What is the ratio of the Exports (in Local Currency Unit) of Mexico in 1986 to that in 1988?
Offer a terse response. 0.17. What is the ratio of the Exports (in Local Currency Unit) of Zambia in 1986 to that in 1988?
Your answer should be very brief. 0.53. What is the ratio of the Exports (in Local Currency Unit) of Chad in 1986 to that in 1989?
Provide a succinct answer. 0.79. What is the ratio of the Exports (in Local Currency Unit) in Comoros in 1986 to that in 1989?
Make the answer very short. 0.98. What is the ratio of the Exports (in Local Currency Unit) of Mexico in 1986 to that in 1989?
Keep it short and to the point. 0.13. What is the ratio of the Exports (in Local Currency Unit) of Zambia in 1986 to that in 1989?
Offer a terse response. 0.37. What is the ratio of the Exports (in Local Currency Unit) in Chad in 1986 to that in 1990?
Provide a short and direct response. 0.78. What is the ratio of the Exports (in Local Currency Unit) in Comoros in 1986 to that in 1990?
Provide a succinct answer. 0.95. What is the ratio of the Exports (in Local Currency Unit) of Mexico in 1986 to that in 1990?
Provide a short and direct response. 0.1. What is the ratio of the Exports (in Local Currency Unit) in Zambia in 1986 to that in 1990?
Provide a succinct answer. 0.13. What is the ratio of the Exports (in Local Currency Unit) of Chad in 1986 to that in 1991?
Your answer should be compact. 0.78. What is the ratio of the Exports (in Local Currency Unit) of Comoros in 1986 to that in 1991?
Make the answer very short. 0.66. What is the ratio of the Exports (in Local Currency Unit) in Mexico in 1986 to that in 1991?
Your answer should be very brief. 0.09. What is the ratio of the Exports (in Local Currency Unit) in Zambia in 1986 to that in 1991?
Provide a short and direct response. 0.07. What is the ratio of the Exports (in Local Currency Unit) in Chad in 1987 to that in 1988?
Your answer should be compact. 0.81. What is the ratio of the Exports (in Local Currency Unit) in Comoros in 1987 to that in 1988?
Provide a succinct answer. 0.81. What is the ratio of the Exports (in Local Currency Unit) of Mexico in 1987 to that in 1988?
Offer a terse response. 0.45. What is the ratio of the Exports (in Local Currency Unit) of Zambia in 1987 to that in 1988?
Offer a very short reply. 0.83. What is the ratio of the Exports (in Local Currency Unit) of Chad in 1987 to that in 1989?
Ensure brevity in your answer.  0.86. What is the ratio of the Exports (in Local Currency Unit) of Comoros in 1987 to that in 1989?
Offer a very short reply. 0.95. What is the ratio of the Exports (in Local Currency Unit) in Mexico in 1987 to that in 1989?
Give a very brief answer. 0.36. What is the ratio of the Exports (in Local Currency Unit) in Zambia in 1987 to that in 1989?
Give a very brief answer. 0.58. What is the ratio of the Exports (in Local Currency Unit) in Chad in 1987 to that in 1990?
Make the answer very short. 0.85. What is the ratio of the Exports (in Local Currency Unit) of Comoros in 1987 to that in 1990?
Offer a terse response. 0.93. What is the ratio of the Exports (in Local Currency Unit) of Mexico in 1987 to that in 1990?
Provide a short and direct response. 0.27. What is the ratio of the Exports (in Local Currency Unit) in Zambia in 1987 to that in 1990?
Offer a very short reply. 0.21. What is the ratio of the Exports (in Local Currency Unit) in Chad in 1987 to that in 1991?
Offer a very short reply. 0.85. What is the ratio of the Exports (in Local Currency Unit) of Comoros in 1987 to that in 1991?
Offer a terse response. 0.65. What is the ratio of the Exports (in Local Currency Unit) in Mexico in 1987 to that in 1991?
Your answer should be compact. 0.24. What is the ratio of the Exports (in Local Currency Unit) in Zambia in 1987 to that in 1991?
Make the answer very short. 0.11. What is the ratio of the Exports (in Local Currency Unit) of Chad in 1988 to that in 1989?
Ensure brevity in your answer.  1.05. What is the ratio of the Exports (in Local Currency Unit) in Comoros in 1988 to that in 1989?
Your response must be concise. 1.18. What is the ratio of the Exports (in Local Currency Unit) in Mexico in 1988 to that in 1989?
Your response must be concise. 0.8. What is the ratio of the Exports (in Local Currency Unit) in Zambia in 1988 to that in 1989?
Make the answer very short. 0.69. What is the ratio of the Exports (in Local Currency Unit) in Chad in 1988 to that in 1990?
Your answer should be very brief. 1.04. What is the ratio of the Exports (in Local Currency Unit) of Comoros in 1988 to that in 1990?
Make the answer very short. 1.15. What is the ratio of the Exports (in Local Currency Unit) in Mexico in 1988 to that in 1990?
Provide a short and direct response. 0.6. What is the ratio of the Exports (in Local Currency Unit) in Zambia in 1988 to that in 1990?
Offer a very short reply. 0.25. What is the ratio of the Exports (in Local Currency Unit) of Chad in 1988 to that in 1991?
Your response must be concise. 1.05. What is the ratio of the Exports (in Local Currency Unit) in Comoros in 1988 to that in 1991?
Give a very brief answer. 0.8. What is the ratio of the Exports (in Local Currency Unit) of Mexico in 1988 to that in 1991?
Keep it short and to the point. 0.53. What is the ratio of the Exports (in Local Currency Unit) in Zambia in 1988 to that in 1991?
Provide a succinct answer. 0.14. What is the ratio of the Exports (in Local Currency Unit) in Chad in 1989 to that in 1990?
Your answer should be very brief. 0.99. What is the ratio of the Exports (in Local Currency Unit) of Comoros in 1989 to that in 1990?
Your answer should be very brief. 0.97. What is the ratio of the Exports (in Local Currency Unit) in Mexico in 1989 to that in 1990?
Your response must be concise. 0.76. What is the ratio of the Exports (in Local Currency Unit) of Zambia in 1989 to that in 1990?
Offer a very short reply. 0.36. What is the ratio of the Exports (in Local Currency Unit) in Comoros in 1989 to that in 1991?
Make the answer very short. 0.68. What is the ratio of the Exports (in Local Currency Unit) in Mexico in 1989 to that in 1991?
Provide a succinct answer. 0.67. What is the ratio of the Exports (in Local Currency Unit) of Zambia in 1989 to that in 1991?
Keep it short and to the point. 0.2. What is the ratio of the Exports (in Local Currency Unit) in Chad in 1990 to that in 1991?
Your answer should be compact. 1.01. What is the ratio of the Exports (in Local Currency Unit) in Comoros in 1990 to that in 1991?
Offer a terse response. 0.7. What is the ratio of the Exports (in Local Currency Unit) of Mexico in 1990 to that in 1991?
Provide a short and direct response. 0.88. What is the ratio of the Exports (in Local Currency Unit) of Zambia in 1990 to that in 1991?
Your answer should be compact. 0.54. What is the difference between the highest and the second highest Exports (in Local Currency Unit) in Chad?
Keep it short and to the point. 2.51e+09. What is the difference between the highest and the second highest Exports (in Local Currency Unit) of Comoros?
Offer a terse response. 2.82e+09. What is the difference between the highest and the second highest Exports (in Local Currency Unit) of Mexico?
Your answer should be compact. 1.79e+1. What is the difference between the highest and the second highest Exports (in Local Currency Unit) of Zambia?
Keep it short and to the point. 3.49e+07. What is the difference between the highest and the lowest Exports (in Local Currency Unit) of Chad?
Provide a short and direct response. 1.68e+1. What is the difference between the highest and the lowest Exports (in Local Currency Unit) of Comoros?
Ensure brevity in your answer.  4.93e+09. What is the difference between the highest and the lowest Exports (in Local Currency Unit) in Mexico?
Offer a very short reply. 1.42e+11. What is the difference between the highest and the lowest Exports (in Local Currency Unit) in Zambia?
Offer a very short reply. 7.01e+07. 